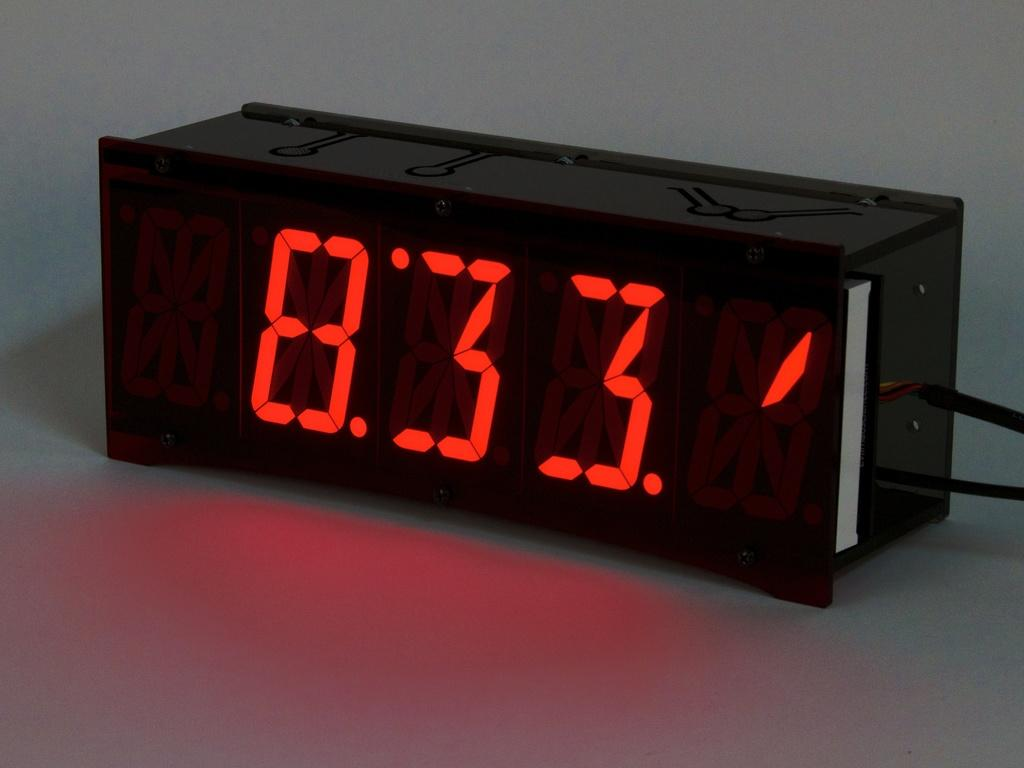<image>
Describe the image concisely. A black digital clock reads 833 in red numbers. 